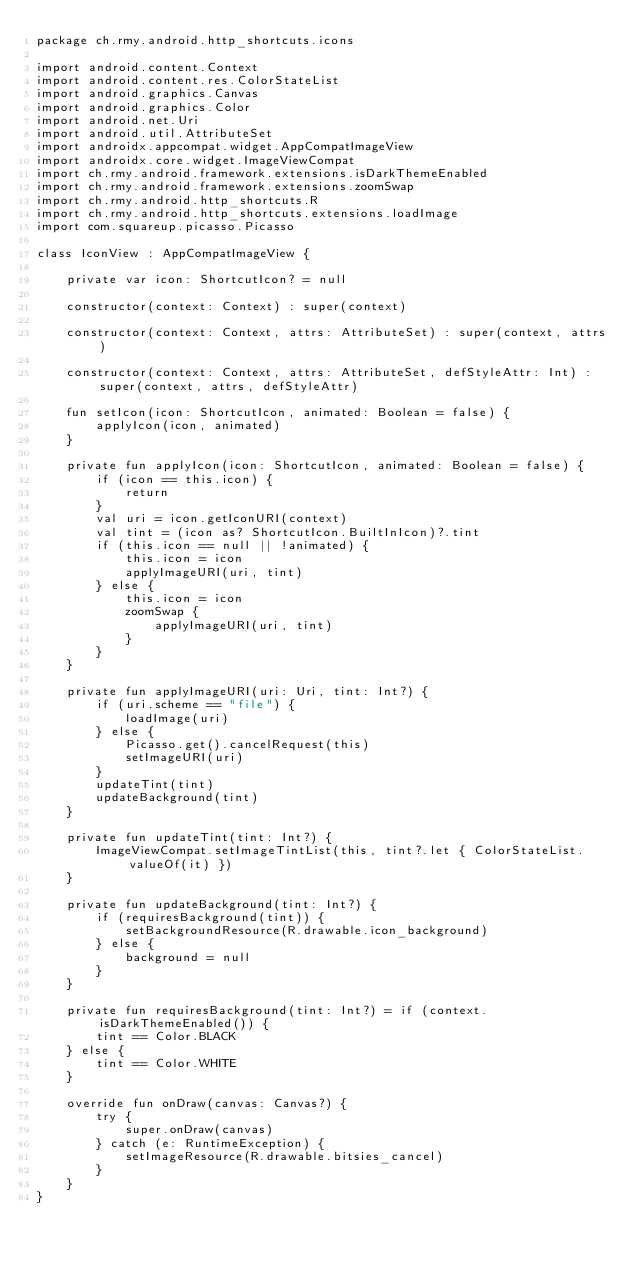<code> <loc_0><loc_0><loc_500><loc_500><_Kotlin_>package ch.rmy.android.http_shortcuts.icons

import android.content.Context
import android.content.res.ColorStateList
import android.graphics.Canvas
import android.graphics.Color
import android.net.Uri
import android.util.AttributeSet
import androidx.appcompat.widget.AppCompatImageView
import androidx.core.widget.ImageViewCompat
import ch.rmy.android.framework.extensions.isDarkThemeEnabled
import ch.rmy.android.framework.extensions.zoomSwap
import ch.rmy.android.http_shortcuts.R
import ch.rmy.android.http_shortcuts.extensions.loadImage
import com.squareup.picasso.Picasso

class IconView : AppCompatImageView {

    private var icon: ShortcutIcon? = null

    constructor(context: Context) : super(context)

    constructor(context: Context, attrs: AttributeSet) : super(context, attrs)

    constructor(context: Context, attrs: AttributeSet, defStyleAttr: Int) : super(context, attrs, defStyleAttr)

    fun setIcon(icon: ShortcutIcon, animated: Boolean = false) {
        applyIcon(icon, animated)
    }

    private fun applyIcon(icon: ShortcutIcon, animated: Boolean = false) {
        if (icon == this.icon) {
            return
        }
        val uri = icon.getIconURI(context)
        val tint = (icon as? ShortcutIcon.BuiltInIcon)?.tint
        if (this.icon == null || !animated) {
            this.icon = icon
            applyImageURI(uri, tint)
        } else {
            this.icon = icon
            zoomSwap {
                applyImageURI(uri, tint)
            }
        }
    }

    private fun applyImageURI(uri: Uri, tint: Int?) {
        if (uri.scheme == "file") {
            loadImage(uri)
        } else {
            Picasso.get().cancelRequest(this)
            setImageURI(uri)
        }
        updateTint(tint)
        updateBackground(tint)
    }

    private fun updateTint(tint: Int?) {
        ImageViewCompat.setImageTintList(this, tint?.let { ColorStateList.valueOf(it) })
    }

    private fun updateBackground(tint: Int?) {
        if (requiresBackground(tint)) {
            setBackgroundResource(R.drawable.icon_background)
        } else {
            background = null
        }
    }

    private fun requiresBackground(tint: Int?) = if (context.isDarkThemeEnabled()) {
        tint == Color.BLACK
    } else {
        tint == Color.WHITE
    }

    override fun onDraw(canvas: Canvas?) {
        try {
            super.onDraw(canvas)
        } catch (e: RuntimeException) {
            setImageResource(R.drawable.bitsies_cancel)
        }
    }
}
</code> 